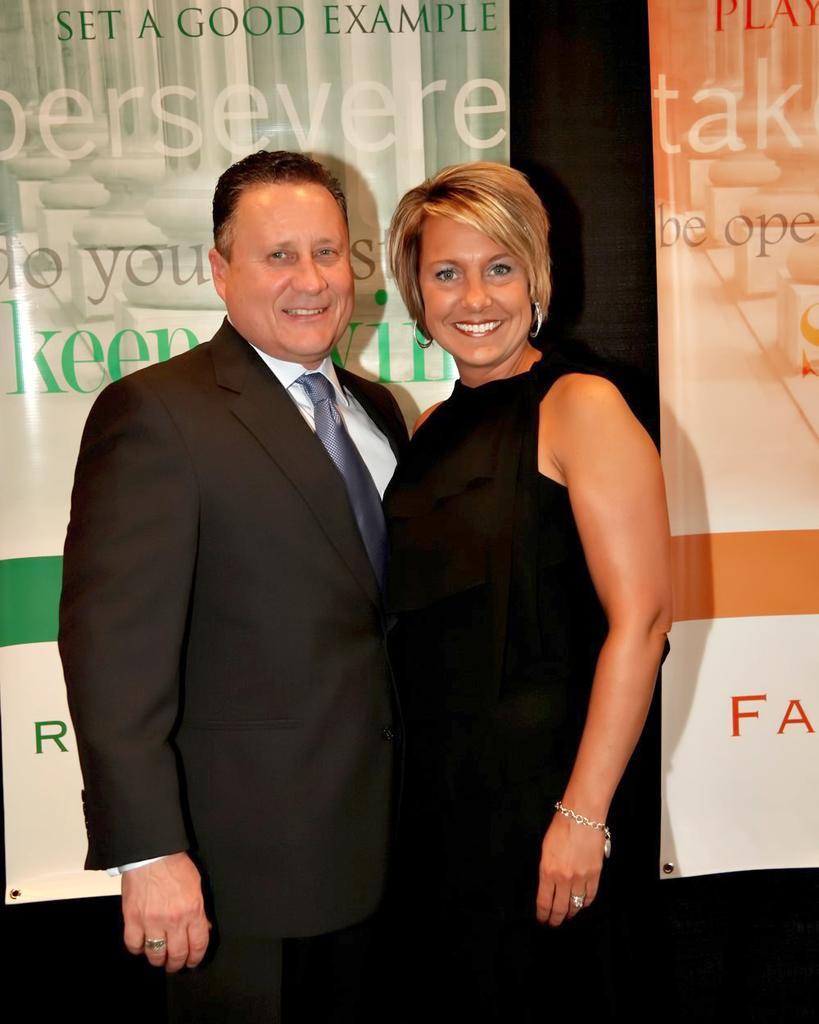Can you describe this image briefly? In the center of the image we can see a man and a lady standing and smiling. In the background there are banners. 